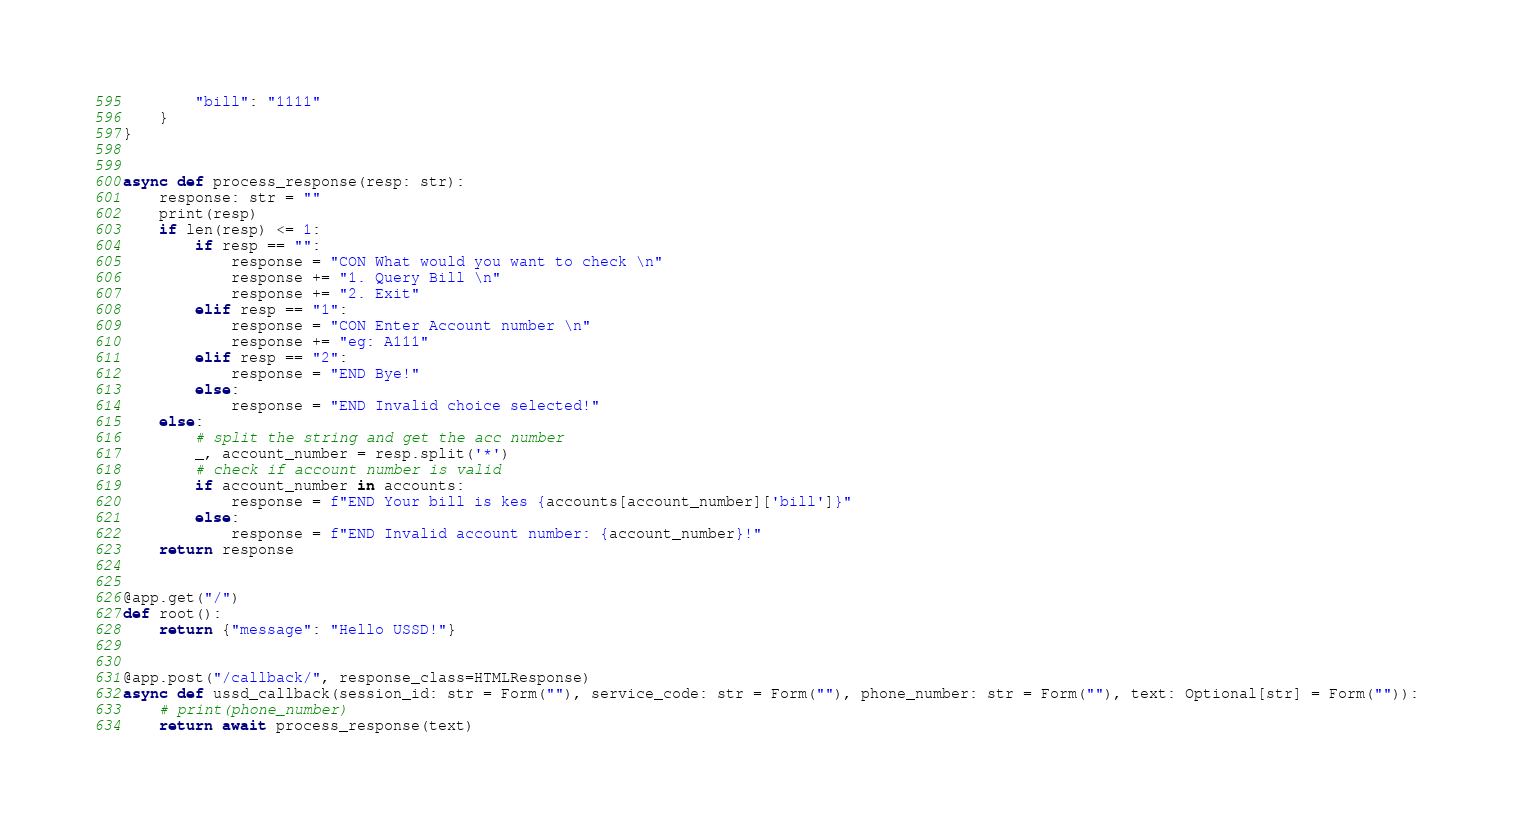Convert code to text. <code><loc_0><loc_0><loc_500><loc_500><_Python_>        "bill": "1111"
    }
}


async def process_response(resp: str):
    response: str = ""
    print(resp)
    if len(resp) <= 1:
        if resp == "":
            response = "CON What would you want to check \n"
            response += "1. Query Bill \n"
            response += "2. Exit"
        elif resp == "1":
            response = "CON Enter Account number \n"
            response += "eg: A111"
        elif resp == "2":
            response = "END Bye!"
        else:
            response = "END Invalid choice selected!"
    else:
        # split the string and get the acc number
        _, account_number = resp.split('*')
        # check if account number is valid
        if account_number in accounts:
            response = f"END Your bill is kes {accounts[account_number]['bill']}"
        else:
            response = f"END Invalid account number: {account_number}!"
    return response


@app.get("/")
def root():
    return {"message": "Hello USSD!"}


@app.post("/callback/", response_class=HTMLResponse)
async def ussd_callback(session_id: str = Form(""), service_code: str = Form(""), phone_number: str = Form(""), text: Optional[str] = Form("")):
    # print(phone_number)
    return await process_response(text)
</code> 